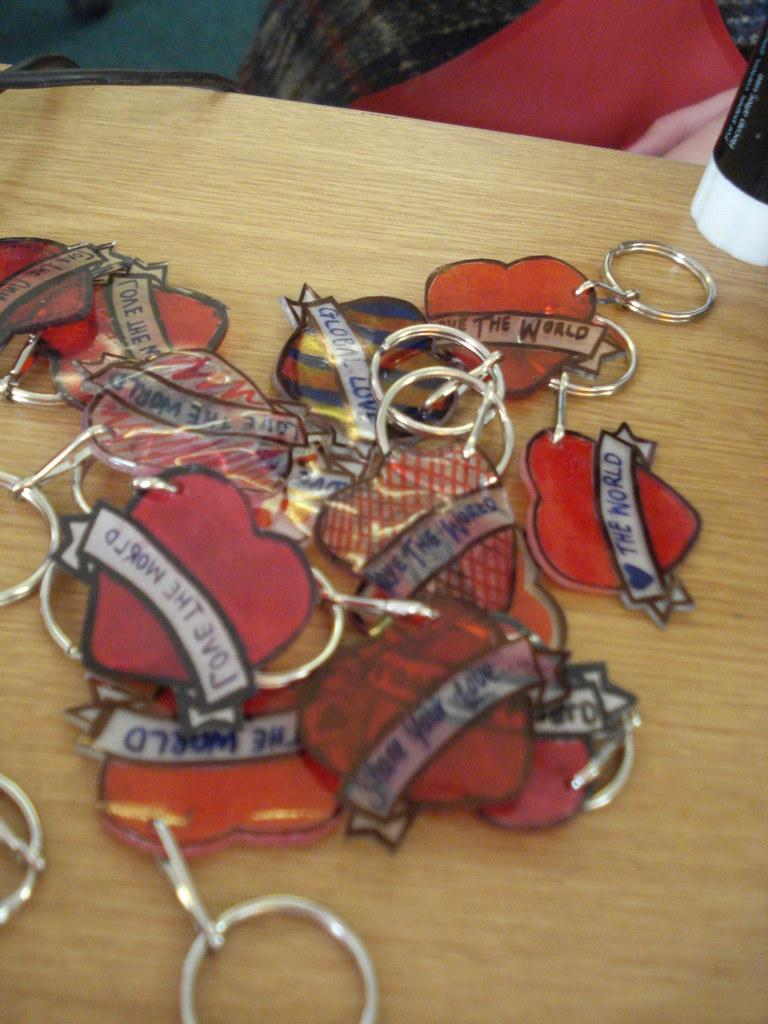What type of objects are on the wooden surface in the image? There are key chains on the wooden surface in the image. What shape are the key chains? The key chains are in the shape of a heart. Are there any words or letters on the key chains? Yes, there is text on the key chains. Can you describe the object in the top right corner of the image? Unfortunately, the facts provided do not give any information about the object in the top right corner of the image. How does the tiger cause trouble in the image? There is no tiger present in the image, so it cannot cause any trouble. 